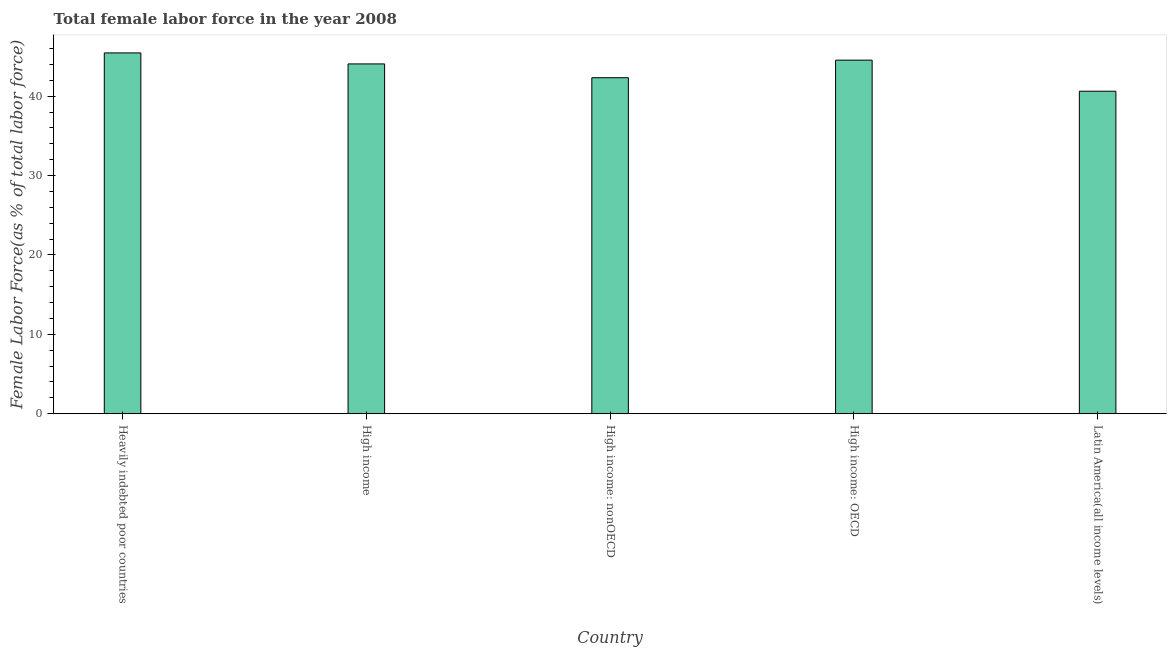Does the graph contain any zero values?
Make the answer very short. No. Does the graph contain grids?
Ensure brevity in your answer.  No. What is the title of the graph?
Offer a terse response. Total female labor force in the year 2008. What is the label or title of the X-axis?
Provide a short and direct response. Country. What is the label or title of the Y-axis?
Keep it short and to the point. Female Labor Force(as % of total labor force). What is the total female labor force in Heavily indebted poor countries?
Ensure brevity in your answer.  45.46. Across all countries, what is the maximum total female labor force?
Provide a succinct answer. 45.46. Across all countries, what is the minimum total female labor force?
Provide a short and direct response. 40.63. In which country was the total female labor force maximum?
Make the answer very short. Heavily indebted poor countries. In which country was the total female labor force minimum?
Provide a succinct answer. Latin America(all income levels). What is the sum of the total female labor force?
Offer a very short reply. 217.05. What is the difference between the total female labor force in Heavily indebted poor countries and Latin America(all income levels)?
Your response must be concise. 4.83. What is the average total female labor force per country?
Ensure brevity in your answer.  43.41. What is the median total female labor force?
Offer a very short reply. 44.07. What is the ratio of the total female labor force in High income: OECD to that in Latin America(all income levels)?
Your answer should be compact. 1.1. Is the total female labor force in Heavily indebted poor countries less than that in High income: OECD?
Ensure brevity in your answer.  No. What is the difference between the highest and the second highest total female labor force?
Make the answer very short. 0.91. Is the sum of the total female labor force in High income and Latin America(all income levels) greater than the maximum total female labor force across all countries?
Keep it short and to the point. Yes. What is the difference between the highest and the lowest total female labor force?
Your response must be concise. 4.83. In how many countries, is the total female labor force greater than the average total female labor force taken over all countries?
Offer a terse response. 3. Are all the bars in the graph horizontal?
Your answer should be very brief. No. Are the values on the major ticks of Y-axis written in scientific E-notation?
Make the answer very short. No. What is the Female Labor Force(as % of total labor force) in Heavily indebted poor countries?
Ensure brevity in your answer.  45.46. What is the Female Labor Force(as % of total labor force) in High income?
Your response must be concise. 44.07. What is the Female Labor Force(as % of total labor force) of High income: nonOECD?
Your answer should be compact. 42.34. What is the Female Labor Force(as % of total labor force) of High income: OECD?
Provide a short and direct response. 44.55. What is the Female Labor Force(as % of total labor force) in Latin America(all income levels)?
Your answer should be compact. 40.63. What is the difference between the Female Labor Force(as % of total labor force) in Heavily indebted poor countries and High income?
Your answer should be very brief. 1.39. What is the difference between the Female Labor Force(as % of total labor force) in Heavily indebted poor countries and High income: nonOECD?
Keep it short and to the point. 3.12. What is the difference between the Female Labor Force(as % of total labor force) in Heavily indebted poor countries and High income: OECD?
Make the answer very short. 0.91. What is the difference between the Female Labor Force(as % of total labor force) in Heavily indebted poor countries and Latin America(all income levels)?
Your answer should be very brief. 4.83. What is the difference between the Female Labor Force(as % of total labor force) in High income and High income: nonOECD?
Your answer should be compact. 1.74. What is the difference between the Female Labor Force(as % of total labor force) in High income and High income: OECD?
Your answer should be compact. -0.48. What is the difference between the Female Labor Force(as % of total labor force) in High income and Latin America(all income levels)?
Your answer should be compact. 3.44. What is the difference between the Female Labor Force(as % of total labor force) in High income: nonOECD and High income: OECD?
Offer a very short reply. -2.21. What is the difference between the Female Labor Force(as % of total labor force) in High income: nonOECD and Latin America(all income levels)?
Provide a short and direct response. 1.7. What is the difference between the Female Labor Force(as % of total labor force) in High income: OECD and Latin America(all income levels)?
Provide a succinct answer. 3.91. What is the ratio of the Female Labor Force(as % of total labor force) in Heavily indebted poor countries to that in High income?
Make the answer very short. 1.03. What is the ratio of the Female Labor Force(as % of total labor force) in Heavily indebted poor countries to that in High income: nonOECD?
Your response must be concise. 1.07. What is the ratio of the Female Labor Force(as % of total labor force) in Heavily indebted poor countries to that in High income: OECD?
Provide a succinct answer. 1.02. What is the ratio of the Female Labor Force(as % of total labor force) in Heavily indebted poor countries to that in Latin America(all income levels)?
Offer a very short reply. 1.12. What is the ratio of the Female Labor Force(as % of total labor force) in High income to that in High income: nonOECD?
Give a very brief answer. 1.04. What is the ratio of the Female Labor Force(as % of total labor force) in High income to that in Latin America(all income levels)?
Your answer should be very brief. 1.08. What is the ratio of the Female Labor Force(as % of total labor force) in High income: nonOECD to that in High income: OECD?
Provide a short and direct response. 0.95. What is the ratio of the Female Labor Force(as % of total labor force) in High income: nonOECD to that in Latin America(all income levels)?
Your response must be concise. 1.04. What is the ratio of the Female Labor Force(as % of total labor force) in High income: OECD to that in Latin America(all income levels)?
Your answer should be very brief. 1.1. 